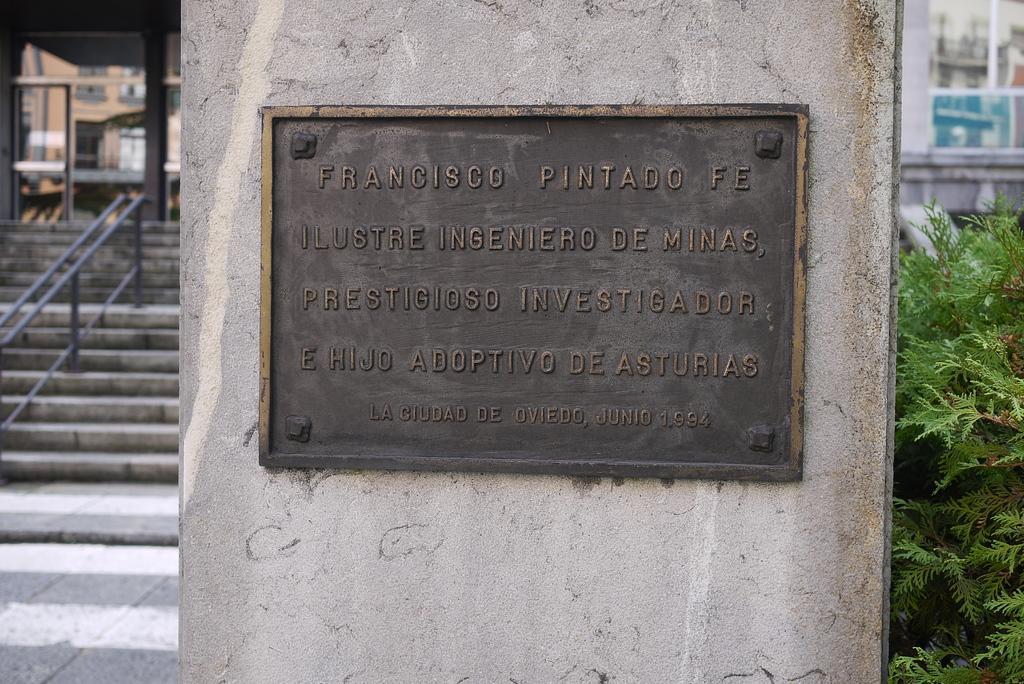How would you summarize this image in a sentence or two? In the picture there is a wall, on the wall there is a board with the text, beside there are concrete stairs and an iron pole fence, there is a plant, there may be a building. 